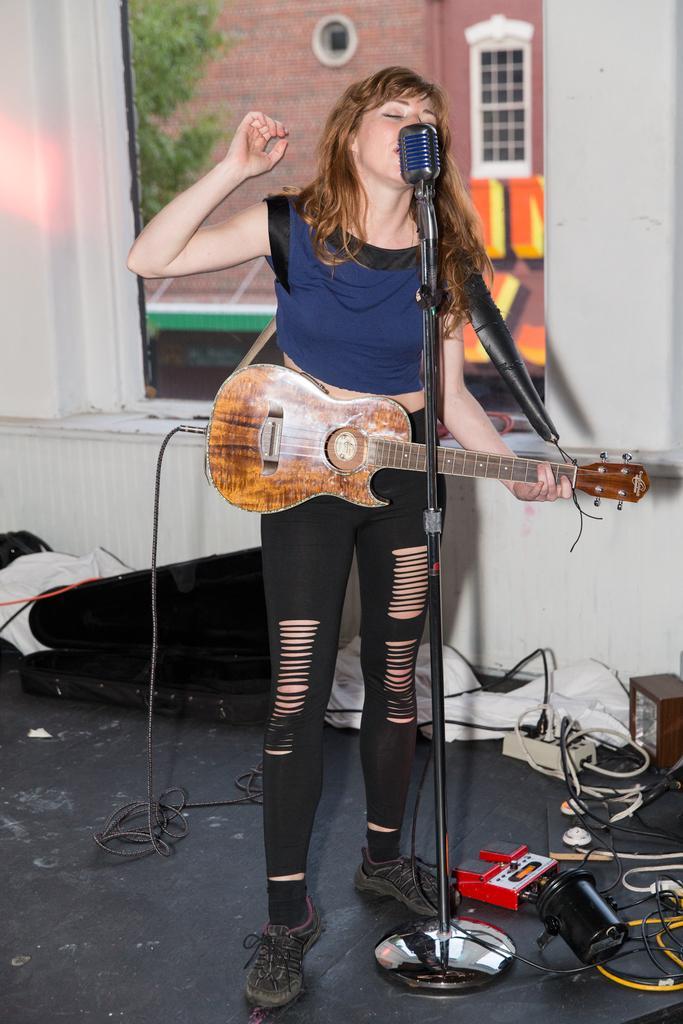Can you describe this image briefly? In the image we can see there is a woman who is standing and holding guitar in her hand and in front of her there is a mic. 